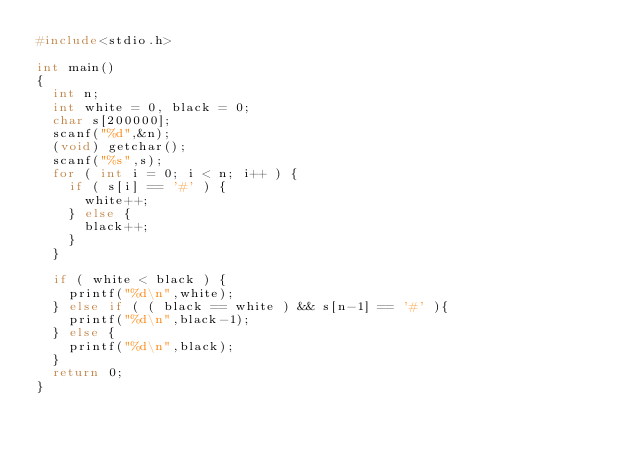Convert code to text. <code><loc_0><loc_0><loc_500><loc_500><_C_>#include<stdio.h>

int main()
{
  int n;
  int white = 0, black = 0;
  char s[200000];
  scanf("%d",&n);
  (void) getchar();
  scanf("%s",s);
  for ( int i = 0; i < n; i++ ) {
    if ( s[i] == '#' ) {
      white++;
    } else {
      black++;
    }
  }

  if ( white < black ) {
    printf("%d\n",white);
  } else if ( ( black == white ) && s[n-1] == '#' ){
    printf("%d\n",black-1);
  } else {
    printf("%d\n",black);
  }
  return 0;
}</code> 